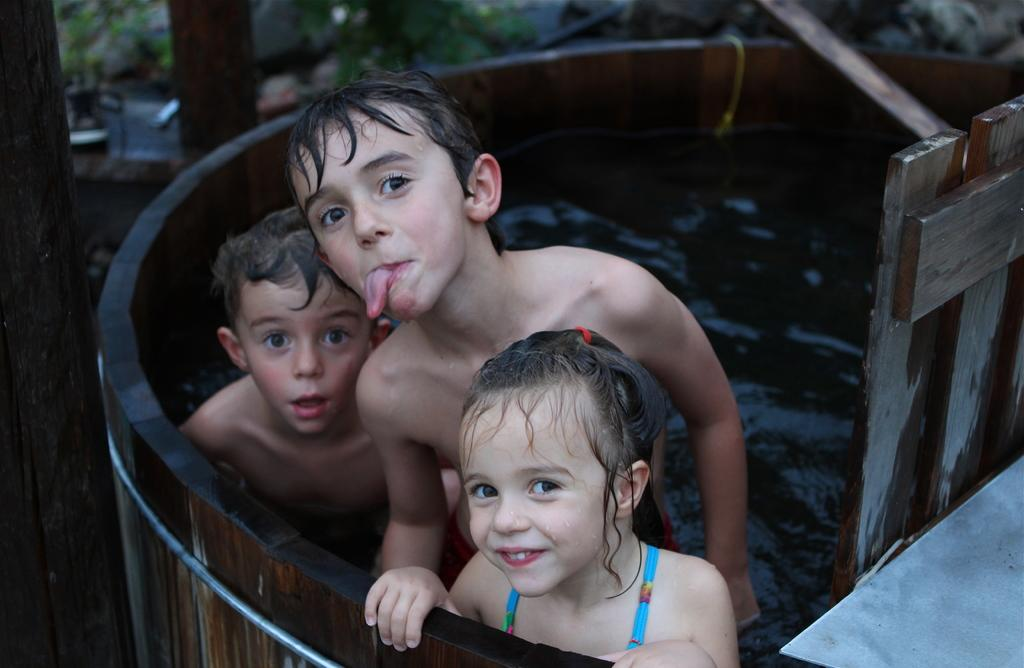Who is present in the image? There are kids in the image. Where are the kids located? The kids are in a tank. What can be seen on the left side of the image? There is a pole on the left side of the image. What type of fork can be seen in the image? There is no fork present in the image; it features kids in a tank with a pole on the left side. 